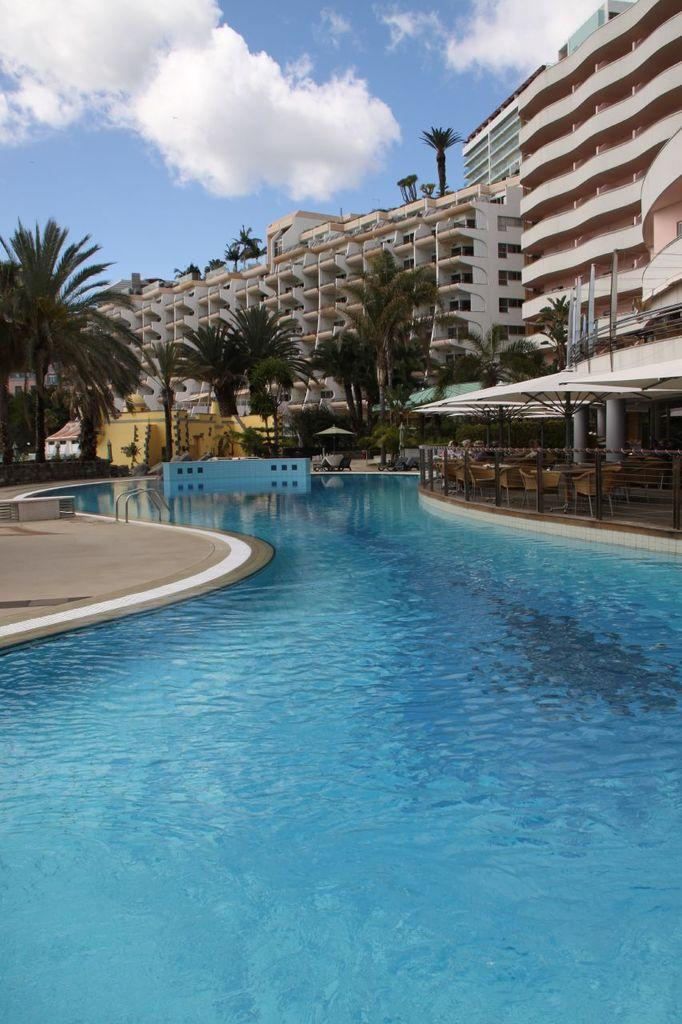What is the main feature of the image? There is water in a swimming pool in the image. What can be seen in the background of the image? There are trees visible in the image. What structures are present in the image? There are poles, chairs, tents, and buildings in the image. What is visible in the sky in the image? There are clouds in the sky in the image. How does the shade of the trees affect the tents in the image? There is no mention of shade in the image, so we cannot determine its effect on the tents. What do you believe the people in the image are thinking? We cannot determine the thoughts of the people in the image based on the provided facts. 